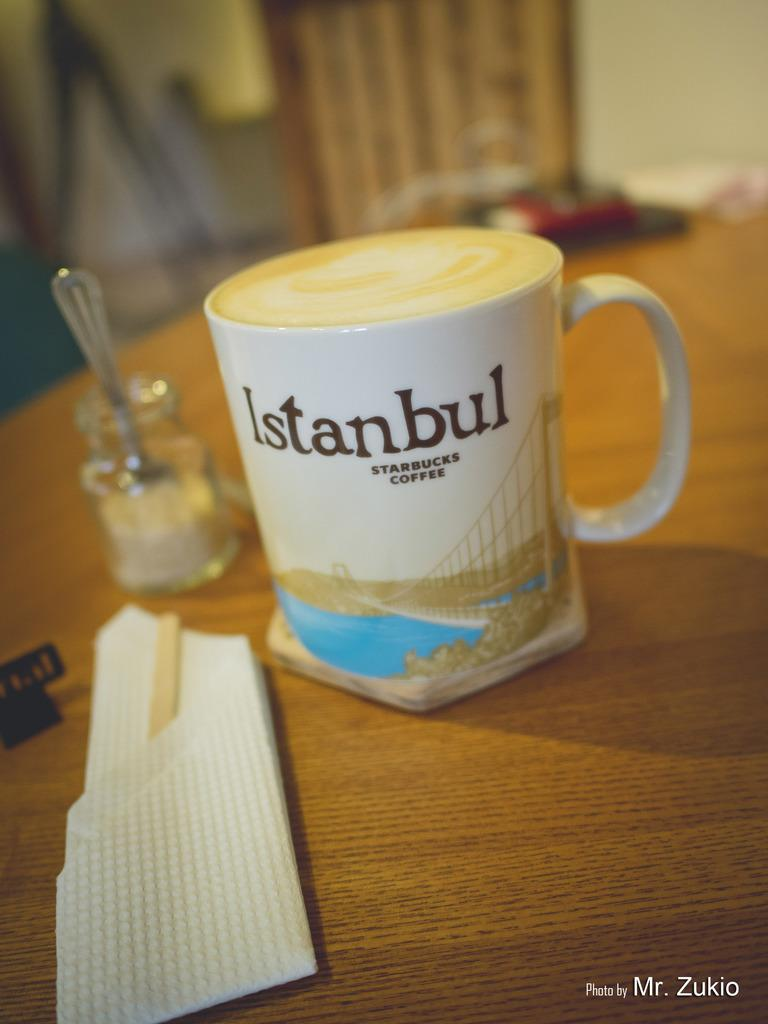<image>
Create a compact narrative representing the image presented. a cup with the word Istanbul on the top of it 